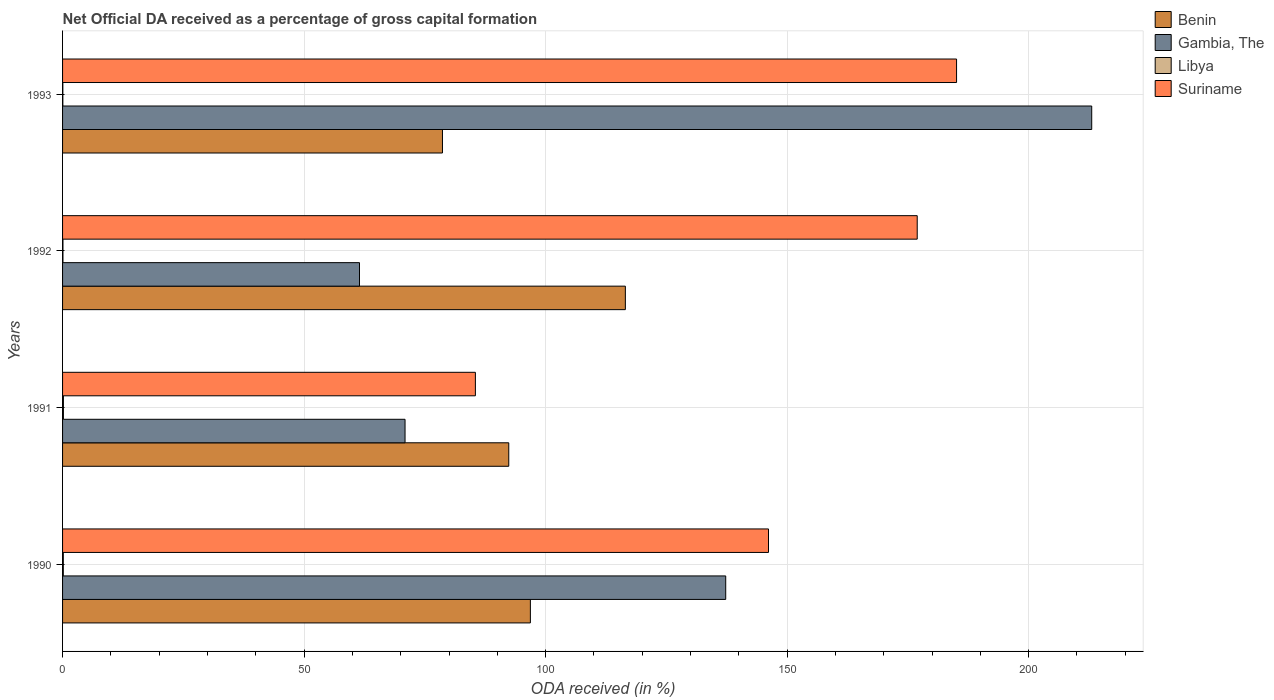How many different coloured bars are there?
Make the answer very short. 4. How many groups of bars are there?
Offer a terse response. 4. How many bars are there on the 3rd tick from the bottom?
Ensure brevity in your answer.  4. What is the label of the 3rd group of bars from the top?
Give a very brief answer. 1991. In how many cases, is the number of bars for a given year not equal to the number of legend labels?
Give a very brief answer. 0. What is the net ODA received in Gambia, The in 1992?
Provide a short and direct response. 61.47. Across all years, what is the maximum net ODA received in Benin?
Keep it short and to the point. 116.51. Across all years, what is the minimum net ODA received in Suriname?
Make the answer very short. 85.46. In which year was the net ODA received in Libya maximum?
Your answer should be very brief. 1991. In which year was the net ODA received in Benin minimum?
Your answer should be very brief. 1993. What is the total net ODA received in Suriname in the graph?
Your response must be concise. 593.6. What is the difference between the net ODA received in Libya in 1990 and that in 1993?
Ensure brevity in your answer.  0.1. What is the difference between the net ODA received in Benin in 1992 and the net ODA received in Gambia, The in 1991?
Provide a short and direct response. 45.61. What is the average net ODA received in Libya per year?
Your answer should be very brief. 0.12. In the year 1992, what is the difference between the net ODA received in Benin and net ODA received in Libya?
Make the answer very short. 116.43. In how many years, is the net ODA received in Libya greater than 180 %?
Offer a very short reply. 0. What is the ratio of the net ODA received in Suriname in 1990 to that in 1993?
Give a very brief answer. 0.79. Is the difference between the net ODA received in Benin in 1990 and 1991 greater than the difference between the net ODA received in Libya in 1990 and 1991?
Offer a very short reply. Yes. What is the difference between the highest and the second highest net ODA received in Suriname?
Offer a very short reply. 8.14. What is the difference between the highest and the lowest net ODA received in Benin?
Provide a short and direct response. 37.86. Is the sum of the net ODA received in Suriname in 1992 and 1993 greater than the maximum net ODA received in Gambia, The across all years?
Give a very brief answer. Yes. Is it the case that in every year, the sum of the net ODA received in Libya and net ODA received in Gambia, The is greater than the sum of net ODA received in Benin and net ODA received in Suriname?
Offer a very short reply. Yes. What does the 4th bar from the top in 1990 represents?
Give a very brief answer. Benin. What does the 3rd bar from the bottom in 1992 represents?
Keep it short and to the point. Libya. Is it the case that in every year, the sum of the net ODA received in Benin and net ODA received in Suriname is greater than the net ODA received in Libya?
Make the answer very short. Yes. How many bars are there?
Your answer should be very brief. 16. How many years are there in the graph?
Provide a succinct answer. 4. Are the values on the major ticks of X-axis written in scientific E-notation?
Keep it short and to the point. No. Does the graph contain grids?
Provide a succinct answer. Yes. How many legend labels are there?
Provide a succinct answer. 4. What is the title of the graph?
Make the answer very short. Net Official DA received as a percentage of gross capital formation. What is the label or title of the X-axis?
Give a very brief answer. ODA received (in %). What is the label or title of the Y-axis?
Your answer should be very brief. Years. What is the ODA received (in %) of Benin in 1990?
Your answer should be very brief. 96.84. What is the ODA received (in %) of Gambia, The in 1990?
Your response must be concise. 137.28. What is the ODA received (in %) in Libya in 1990?
Offer a terse response. 0.15. What is the ODA received (in %) in Suriname in 1990?
Your answer should be very brief. 146.14. What is the ODA received (in %) in Benin in 1991?
Offer a very short reply. 92.37. What is the ODA received (in %) of Gambia, The in 1991?
Offer a very short reply. 70.9. What is the ODA received (in %) of Libya in 1991?
Keep it short and to the point. 0.18. What is the ODA received (in %) of Suriname in 1991?
Make the answer very short. 85.46. What is the ODA received (in %) of Benin in 1992?
Your answer should be very brief. 116.51. What is the ODA received (in %) of Gambia, The in 1992?
Offer a very short reply. 61.47. What is the ODA received (in %) of Libya in 1992?
Make the answer very short. 0.08. What is the ODA received (in %) of Suriname in 1992?
Offer a terse response. 176.93. What is the ODA received (in %) in Benin in 1993?
Provide a succinct answer. 78.65. What is the ODA received (in %) of Gambia, The in 1993?
Your answer should be very brief. 213.05. What is the ODA received (in %) of Libya in 1993?
Ensure brevity in your answer.  0.06. What is the ODA received (in %) of Suriname in 1993?
Offer a very short reply. 185.07. Across all years, what is the maximum ODA received (in %) of Benin?
Your response must be concise. 116.51. Across all years, what is the maximum ODA received (in %) in Gambia, The?
Provide a short and direct response. 213.05. Across all years, what is the maximum ODA received (in %) of Libya?
Your answer should be very brief. 0.18. Across all years, what is the maximum ODA received (in %) of Suriname?
Your answer should be compact. 185.07. Across all years, what is the minimum ODA received (in %) of Benin?
Offer a terse response. 78.65. Across all years, what is the minimum ODA received (in %) in Gambia, The?
Provide a short and direct response. 61.47. Across all years, what is the minimum ODA received (in %) of Libya?
Offer a terse response. 0.06. Across all years, what is the minimum ODA received (in %) in Suriname?
Make the answer very short. 85.46. What is the total ODA received (in %) of Benin in the graph?
Your answer should be very brief. 384.37. What is the total ODA received (in %) in Gambia, The in the graph?
Keep it short and to the point. 482.71. What is the total ODA received (in %) of Libya in the graph?
Your answer should be compact. 0.47. What is the total ODA received (in %) of Suriname in the graph?
Your answer should be compact. 593.6. What is the difference between the ODA received (in %) of Benin in 1990 and that in 1991?
Provide a short and direct response. 4.47. What is the difference between the ODA received (in %) in Gambia, The in 1990 and that in 1991?
Provide a succinct answer. 66.38. What is the difference between the ODA received (in %) in Libya in 1990 and that in 1991?
Offer a very short reply. -0.02. What is the difference between the ODA received (in %) in Suriname in 1990 and that in 1991?
Keep it short and to the point. 60.68. What is the difference between the ODA received (in %) of Benin in 1990 and that in 1992?
Your answer should be compact. -19.66. What is the difference between the ODA received (in %) of Gambia, The in 1990 and that in 1992?
Your answer should be compact. 75.81. What is the difference between the ODA received (in %) in Libya in 1990 and that in 1992?
Offer a terse response. 0.08. What is the difference between the ODA received (in %) of Suriname in 1990 and that in 1992?
Keep it short and to the point. -30.79. What is the difference between the ODA received (in %) in Benin in 1990 and that in 1993?
Provide a succinct answer. 18.2. What is the difference between the ODA received (in %) of Gambia, The in 1990 and that in 1993?
Give a very brief answer. -75.77. What is the difference between the ODA received (in %) of Libya in 1990 and that in 1993?
Offer a terse response. 0.1. What is the difference between the ODA received (in %) of Suriname in 1990 and that in 1993?
Provide a succinct answer. -38.93. What is the difference between the ODA received (in %) of Benin in 1991 and that in 1992?
Give a very brief answer. -24.14. What is the difference between the ODA received (in %) in Gambia, The in 1991 and that in 1992?
Your answer should be very brief. 9.43. What is the difference between the ODA received (in %) in Libya in 1991 and that in 1992?
Provide a succinct answer. 0.1. What is the difference between the ODA received (in %) of Suriname in 1991 and that in 1992?
Make the answer very short. -91.47. What is the difference between the ODA received (in %) of Benin in 1991 and that in 1993?
Keep it short and to the point. 13.72. What is the difference between the ODA received (in %) in Gambia, The in 1991 and that in 1993?
Ensure brevity in your answer.  -142.15. What is the difference between the ODA received (in %) in Libya in 1991 and that in 1993?
Offer a terse response. 0.12. What is the difference between the ODA received (in %) of Suriname in 1991 and that in 1993?
Provide a succinct answer. -99.61. What is the difference between the ODA received (in %) in Benin in 1992 and that in 1993?
Offer a very short reply. 37.86. What is the difference between the ODA received (in %) of Gambia, The in 1992 and that in 1993?
Ensure brevity in your answer.  -151.58. What is the difference between the ODA received (in %) in Libya in 1992 and that in 1993?
Give a very brief answer. 0.02. What is the difference between the ODA received (in %) of Suriname in 1992 and that in 1993?
Provide a succinct answer. -8.14. What is the difference between the ODA received (in %) of Benin in 1990 and the ODA received (in %) of Gambia, The in 1991?
Your answer should be compact. 25.94. What is the difference between the ODA received (in %) in Benin in 1990 and the ODA received (in %) in Libya in 1991?
Your answer should be very brief. 96.67. What is the difference between the ODA received (in %) in Benin in 1990 and the ODA received (in %) in Suriname in 1991?
Your answer should be compact. 11.38. What is the difference between the ODA received (in %) in Gambia, The in 1990 and the ODA received (in %) in Libya in 1991?
Ensure brevity in your answer.  137.1. What is the difference between the ODA received (in %) in Gambia, The in 1990 and the ODA received (in %) in Suriname in 1991?
Make the answer very short. 51.82. What is the difference between the ODA received (in %) of Libya in 1990 and the ODA received (in %) of Suriname in 1991?
Your answer should be compact. -85.31. What is the difference between the ODA received (in %) of Benin in 1990 and the ODA received (in %) of Gambia, The in 1992?
Offer a terse response. 35.37. What is the difference between the ODA received (in %) in Benin in 1990 and the ODA received (in %) in Libya in 1992?
Provide a short and direct response. 96.76. What is the difference between the ODA received (in %) of Benin in 1990 and the ODA received (in %) of Suriname in 1992?
Keep it short and to the point. -80.08. What is the difference between the ODA received (in %) in Gambia, The in 1990 and the ODA received (in %) in Libya in 1992?
Give a very brief answer. 137.2. What is the difference between the ODA received (in %) in Gambia, The in 1990 and the ODA received (in %) in Suriname in 1992?
Make the answer very short. -39.65. What is the difference between the ODA received (in %) of Libya in 1990 and the ODA received (in %) of Suriname in 1992?
Provide a short and direct response. -176.77. What is the difference between the ODA received (in %) in Benin in 1990 and the ODA received (in %) in Gambia, The in 1993?
Keep it short and to the point. -116.21. What is the difference between the ODA received (in %) in Benin in 1990 and the ODA received (in %) in Libya in 1993?
Keep it short and to the point. 96.79. What is the difference between the ODA received (in %) of Benin in 1990 and the ODA received (in %) of Suriname in 1993?
Give a very brief answer. -88.23. What is the difference between the ODA received (in %) in Gambia, The in 1990 and the ODA received (in %) in Libya in 1993?
Offer a terse response. 137.22. What is the difference between the ODA received (in %) of Gambia, The in 1990 and the ODA received (in %) of Suriname in 1993?
Your response must be concise. -47.79. What is the difference between the ODA received (in %) of Libya in 1990 and the ODA received (in %) of Suriname in 1993?
Ensure brevity in your answer.  -184.92. What is the difference between the ODA received (in %) of Benin in 1991 and the ODA received (in %) of Gambia, The in 1992?
Offer a terse response. 30.9. What is the difference between the ODA received (in %) in Benin in 1991 and the ODA received (in %) in Libya in 1992?
Keep it short and to the point. 92.29. What is the difference between the ODA received (in %) in Benin in 1991 and the ODA received (in %) in Suriname in 1992?
Provide a short and direct response. -84.56. What is the difference between the ODA received (in %) in Gambia, The in 1991 and the ODA received (in %) in Libya in 1992?
Provide a short and direct response. 70.82. What is the difference between the ODA received (in %) in Gambia, The in 1991 and the ODA received (in %) in Suriname in 1992?
Your response must be concise. -106.03. What is the difference between the ODA received (in %) in Libya in 1991 and the ODA received (in %) in Suriname in 1992?
Keep it short and to the point. -176.75. What is the difference between the ODA received (in %) of Benin in 1991 and the ODA received (in %) of Gambia, The in 1993?
Your response must be concise. -120.68. What is the difference between the ODA received (in %) in Benin in 1991 and the ODA received (in %) in Libya in 1993?
Your answer should be compact. 92.31. What is the difference between the ODA received (in %) of Benin in 1991 and the ODA received (in %) of Suriname in 1993?
Give a very brief answer. -92.7. What is the difference between the ODA received (in %) of Gambia, The in 1991 and the ODA received (in %) of Libya in 1993?
Give a very brief answer. 70.84. What is the difference between the ODA received (in %) of Gambia, The in 1991 and the ODA received (in %) of Suriname in 1993?
Provide a succinct answer. -114.17. What is the difference between the ODA received (in %) in Libya in 1991 and the ODA received (in %) in Suriname in 1993?
Make the answer very short. -184.89. What is the difference between the ODA received (in %) of Benin in 1992 and the ODA received (in %) of Gambia, The in 1993?
Your answer should be compact. -96.55. What is the difference between the ODA received (in %) in Benin in 1992 and the ODA received (in %) in Libya in 1993?
Provide a succinct answer. 116.45. What is the difference between the ODA received (in %) of Benin in 1992 and the ODA received (in %) of Suriname in 1993?
Your answer should be very brief. -68.56. What is the difference between the ODA received (in %) of Gambia, The in 1992 and the ODA received (in %) of Libya in 1993?
Ensure brevity in your answer.  61.41. What is the difference between the ODA received (in %) of Gambia, The in 1992 and the ODA received (in %) of Suriname in 1993?
Your answer should be very brief. -123.6. What is the difference between the ODA received (in %) of Libya in 1992 and the ODA received (in %) of Suriname in 1993?
Give a very brief answer. -184.99. What is the average ODA received (in %) of Benin per year?
Provide a succinct answer. 96.09. What is the average ODA received (in %) of Gambia, The per year?
Provide a short and direct response. 120.68. What is the average ODA received (in %) in Libya per year?
Offer a very short reply. 0.12. What is the average ODA received (in %) in Suriname per year?
Make the answer very short. 148.4. In the year 1990, what is the difference between the ODA received (in %) in Benin and ODA received (in %) in Gambia, The?
Your answer should be compact. -40.44. In the year 1990, what is the difference between the ODA received (in %) of Benin and ODA received (in %) of Libya?
Provide a short and direct response. 96.69. In the year 1990, what is the difference between the ODA received (in %) in Benin and ODA received (in %) in Suriname?
Make the answer very short. -49.3. In the year 1990, what is the difference between the ODA received (in %) in Gambia, The and ODA received (in %) in Libya?
Ensure brevity in your answer.  137.13. In the year 1990, what is the difference between the ODA received (in %) in Gambia, The and ODA received (in %) in Suriname?
Give a very brief answer. -8.86. In the year 1990, what is the difference between the ODA received (in %) of Libya and ODA received (in %) of Suriname?
Provide a succinct answer. -145.98. In the year 1991, what is the difference between the ODA received (in %) in Benin and ODA received (in %) in Gambia, The?
Provide a short and direct response. 21.47. In the year 1991, what is the difference between the ODA received (in %) in Benin and ODA received (in %) in Libya?
Provide a succinct answer. 92.19. In the year 1991, what is the difference between the ODA received (in %) of Benin and ODA received (in %) of Suriname?
Offer a very short reply. 6.91. In the year 1991, what is the difference between the ODA received (in %) of Gambia, The and ODA received (in %) of Libya?
Your answer should be compact. 70.72. In the year 1991, what is the difference between the ODA received (in %) of Gambia, The and ODA received (in %) of Suriname?
Offer a terse response. -14.56. In the year 1991, what is the difference between the ODA received (in %) of Libya and ODA received (in %) of Suriname?
Give a very brief answer. -85.28. In the year 1992, what is the difference between the ODA received (in %) in Benin and ODA received (in %) in Gambia, The?
Provide a short and direct response. 55.04. In the year 1992, what is the difference between the ODA received (in %) in Benin and ODA received (in %) in Libya?
Your answer should be compact. 116.43. In the year 1992, what is the difference between the ODA received (in %) in Benin and ODA received (in %) in Suriname?
Offer a terse response. -60.42. In the year 1992, what is the difference between the ODA received (in %) in Gambia, The and ODA received (in %) in Libya?
Offer a terse response. 61.39. In the year 1992, what is the difference between the ODA received (in %) of Gambia, The and ODA received (in %) of Suriname?
Provide a succinct answer. -115.46. In the year 1992, what is the difference between the ODA received (in %) in Libya and ODA received (in %) in Suriname?
Your answer should be compact. -176.85. In the year 1993, what is the difference between the ODA received (in %) of Benin and ODA received (in %) of Gambia, The?
Offer a very short reply. -134.41. In the year 1993, what is the difference between the ODA received (in %) of Benin and ODA received (in %) of Libya?
Give a very brief answer. 78.59. In the year 1993, what is the difference between the ODA received (in %) in Benin and ODA received (in %) in Suriname?
Provide a short and direct response. -106.43. In the year 1993, what is the difference between the ODA received (in %) in Gambia, The and ODA received (in %) in Libya?
Your answer should be compact. 213. In the year 1993, what is the difference between the ODA received (in %) in Gambia, The and ODA received (in %) in Suriname?
Keep it short and to the point. 27.98. In the year 1993, what is the difference between the ODA received (in %) in Libya and ODA received (in %) in Suriname?
Give a very brief answer. -185.01. What is the ratio of the ODA received (in %) in Benin in 1990 to that in 1991?
Provide a succinct answer. 1.05. What is the ratio of the ODA received (in %) in Gambia, The in 1990 to that in 1991?
Ensure brevity in your answer.  1.94. What is the ratio of the ODA received (in %) in Libya in 1990 to that in 1991?
Offer a very short reply. 0.87. What is the ratio of the ODA received (in %) in Suriname in 1990 to that in 1991?
Provide a short and direct response. 1.71. What is the ratio of the ODA received (in %) of Benin in 1990 to that in 1992?
Offer a very short reply. 0.83. What is the ratio of the ODA received (in %) in Gambia, The in 1990 to that in 1992?
Give a very brief answer. 2.23. What is the ratio of the ODA received (in %) of Libya in 1990 to that in 1992?
Your answer should be very brief. 1.95. What is the ratio of the ODA received (in %) in Suriname in 1990 to that in 1992?
Offer a very short reply. 0.83. What is the ratio of the ODA received (in %) of Benin in 1990 to that in 1993?
Give a very brief answer. 1.23. What is the ratio of the ODA received (in %) in Gambia, The in 1990 to that in 1993?
Your response must be concise. 0.64. What is the ratio of the ODA received (in %) in Libya in 1990 to that in 1993?
Offer a very short reply. 2.7. What is the ratio of the ODA received (in %) of Suriname in 1990 to that in 1993?
Offer a very short reply. 0.79. What is the ratio of the ODA received (in %) in Benin in 1991 to that in 1992?
Offer a very short reply. 0.79. What is the ratio of the ODA received (in %) of Gambia, The in 1991 to that in 1992?
Your answer should be very brief. 1.15. What is the ratio of the ODA received (in %) of Libya in 1991 to that in 1992?
Provide a succinct answer. 2.24. What is the ratio of the ODA received (in %) in Suriname in 1991 to that in 1992?
Your response must be concise. 0.48. What is the ratio of the ODA received (in %) in Benin in 1991 to that in 1993?
Offer a terse response. 1.17. What is the ratio of the ODA received (in %) of Gambia, The in 1991 to that in 1993?
Keep it short and to the point. 0.33. What is the ratio of the ODA received (in %) in Libya in 1991 to that in 1993?
Keep it short and to the point. 3.1. What is the ratio of the ODA received (in %) in Suriname in 1991 to that in 1993?
Your answer should be compact. 0.46. What is the ratio of the ODA received (in %) in Benin in 1992 to that in 1993?
Provide a short and direct response. 1.48. What is the ratio of the ODA received (in %) of Gambia, The in 1992 to that in 1993?
Provide a short and direct response. 0.29. What is the ratio of the ODA received (in %) in Libya in 1992 to that in 1993?
Offer a very short reply. 1.39. What is the ratio of the ODA received (in %) in Suriname in 1992 to that in 1993?
Make the answer very short. 0.96. What is the difference between the highest and the second highest ODA received (in %) in Benin?
Make the answer very short. 19.66. What is the difference between the highest and the second highest ODA received (in %) of Gambia, The?
Give a very brief answer. 75.77. What is the difference between the highest and the second highest ODA received (in %) of Libya?
Make the answer very short. 0.02. What is the difference between the highest and the second highest ODA received (in %) in Suriname?
Your response must be concise. 8.14. What is the difference between the highest and the lowest ODA received (in %) of Benin?
Provide a succinct answer. 37.86. What is the difference between the highest and the lowest ODA received (in %) in Gambia, The?
Give a very brief answer. 151.58. What is the difference between the highest and the lowest ODA received (in %) of Libya?
Give a very brief answer. 0.12. What is the difference between the highest and the lowest ODA received (in %) of Suriname?
Your response must be concise. 99.61. 